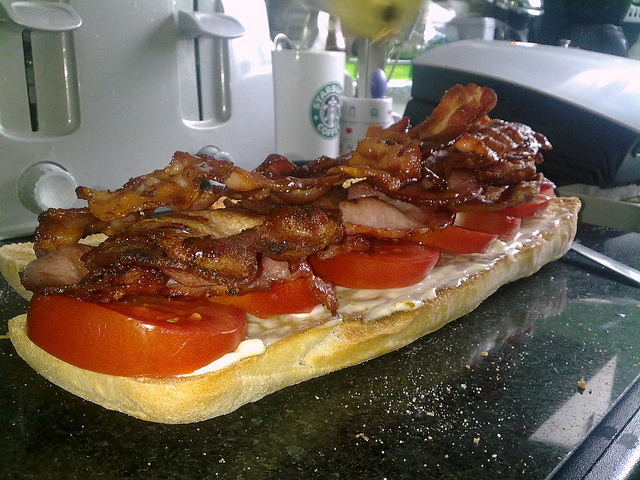What would be a realistic scenario where this sandwich might be found? This sandwich would likely be found in a cozy kitchen setting on a lazy Sunday morning. Perhaps someone decided to whip up a hearty breakfast or lunch, using fresh ingredients they had on hand. The kitchen has a comforting, homey feel, with the smell of freshly brewed coffee wafting through the air. The person making the sandwich takes their time, enjoying the simple pleasure of crafting a delicious meal for themselves or a loved one.  What's a quick description of this sandwich? A delectable sandwich loaded with fresh tomato slices, crispy bacon, and a smear of creamy mayonnaise on a soft baguette. 